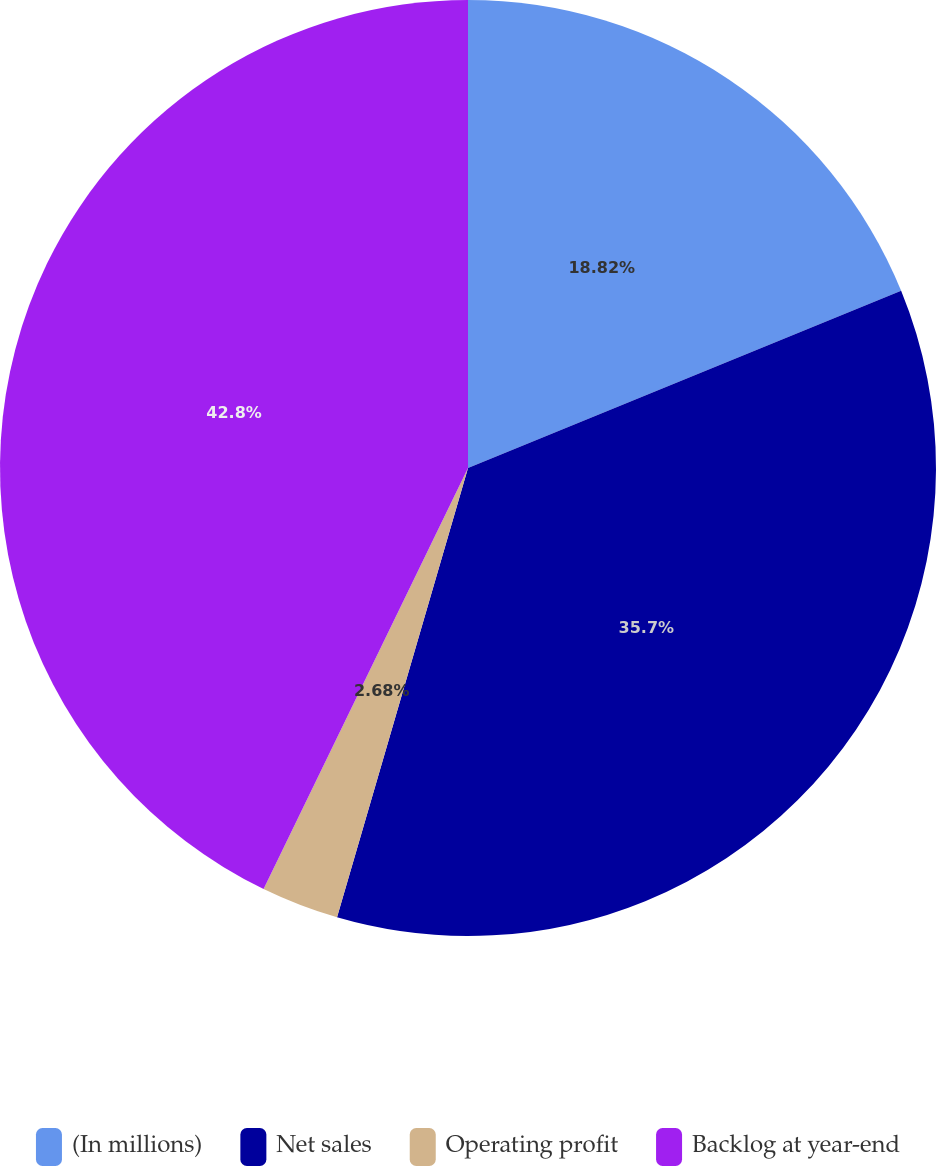Convert chart. <chart><loc_0><loc_0><loc_500><loc_500><pie_chart><fcel>(In millions)<fcel>Net sales<fcel>Operating profit<fcel>Backlog at year-end<nl><fcel>18.82%<fcel>35.7%<fcel>2.68%<fcel>42.81%<nl></chart> 